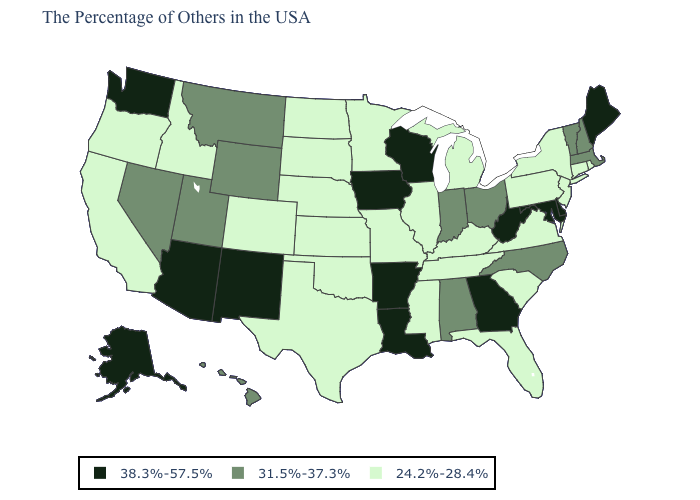Among the states that border Delaware , does Pennsylvania have the highest value?
Concise answer only. No. What is the value of Hawaii?
Keep it brief. 31.5%-37.3%. What is the value of Delaware?
Answer briefly. 38.3%-57.5%. Name the states that have a value in the range 38.3%-57.5%?
Short answer required. Maine, Delaware, Maryland, West Virginia, Georgia, Wisconsin, Louisiana, Arkansas, Iowa, New Mexico, Arizona, Washington, Alaska. What is the value of Michigan?
Be succinct. 24.2%-28.4%. What is the value of Michigan?
Answer briefly. 24.2%-28.4%. Does West Virginia have the lowest value in the South?
Keep it brief. No. Does the first symbol in the legend represent the smallest category?
Quick response, please. No. Which states have the lowest value in the USA?
Give a very brief answer. Rhode Island, Connecticut, New York, New Jersey, Pennsylvania, Virginia, South Carolina, Florida, Michigan, Kentucky, Tennessee, Illinois, Mississippi, Missouri, Minnesota, Kansas, Nebraska, Oklahoma, Texas, South Dakota, North Dakota, Colorado, Idaho, California, Oregon. Does Utah have the same value as North Carolina?
Answer briefly. Yes. Does Massachusetts have the lowest value in the Northeast?
Answer briefly. No. Does Illinois have a lower value than Texas?
Give a very brief answer. No. What is the highest value in the USA?
Give a very brief answer. 38.3%-57.5%. Which states have the lowest value in the Northeast?
Keep it brief. Rhode Island, Connecticut, New York, New Jersey, Pennsylvania. Name the states that have a value in the range 24.2%-28.4%?
Short answer required. Rhode Island, Connecticut, New York, New Jersey, Pennsylvania, Virginia, South Carolina, Florida, Michigan, Kentucky, Tennessee, Illinois, Mississippi, Missouri, Minnesota, Kansas, Nebraska, Oklahoma, Texas, South Dakota, North Dakota, Colorado, Idaho, California, Oregon. 